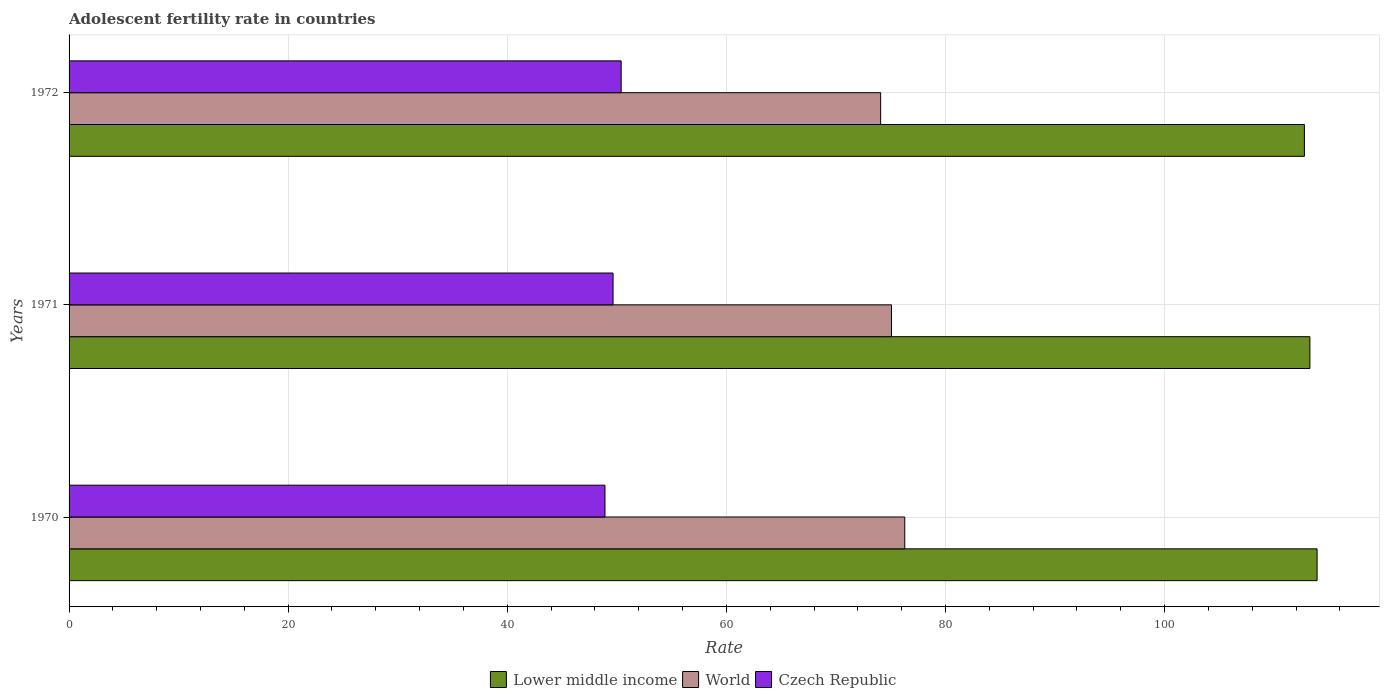How many different coloured bars are there?
Provide a short and direct response. 3. Are the number of bars per tick equal to the number of legend labels?
Ensure brevity in your answer.  Yes. What is the label of the 2nd group of bars from the top?
Keep it short and to the point. 1971. In how many cases, is the number of bars for a given year not equal to the number of legend labels?
Your answer should be compact. 0. What is the adolescent fertility rate in Czech Republic in 1972?
Your response must be concise. 50.4. Across all years, what is the maximum adolescent fertility rate in Lower middle income?
Your answer should be compact. 113.92. Across all years, what is the minimum adolescent fertility rate in Czech Republic?
Make the answer very short. 48.92. In which year was the adolescent fertility rate in World maximum?
Keep it short and to the point. 1970. In which year was the adolescent fertility rate in Lower middle income minimum?
Make the answer very short. 1972. What is the total adolescent fertility rate in World in the graph?
Ensure brevity in your answer.  225.44. What is the difference between the adolescent fertility rate in World in 1971 and that in 1972?
Make the answer very short. 0.99. What is the difference between the adolescent fertility rate in Czech Republic in 1971 and the adolescent fertility rate in Lower middle income in 1972?
Give a very brief answer. -63.11. What is the average adolescent fertility rate in Czech Republic per year?
Provide a succinct answer. 49.66. In the year 1970, what is the difference between the adolescent fertility rate in Lower middle income and adolescent fertility rate in Czech Republic?
Your answer should be compact. 65.01. What is the ratio of the adolescent fertility rate in World in 1970 to that in 1971?
Your answer should be very brief. 1.02. Is the adolescent fertility rate in Czech Republic in 1970 less than that in 1972?
Make the answer very short. Yes. Is the difference between the adolescent fertility rate in Lower middle income in 1970 and 1971 greater than the difference between the adolescent fertility rate in Czech Republic in 1970 and 1971?
Your answer should be compact. Yes. What is the difference between the highest and the second highest adolescent fertility rate in Lower middle income?
Your answer should be compact. 0.66. What is the difference between the highest and the lowest adolescent fertility rate in World?
Provide a short and direct response. 2.2. In how many years, is the adolescent fertility rate in Czech Republic greater than the average adolescent fertility rate in Czech Republic taken over all years?
Your answer should be very brief. 1. What does the 1st bar from the top in 1970 represents?
Your response must be concise. Czech Republic. Is it the case that in every year, the sum of the adolescent fertility rate in Lower middle income and adolescent fertility rate in Czech Republic is greater than the adolescent fertility rate in World?
Your answer should be compact. Yes. How many bars are there?
Offer a terse response. 9. How many years are there in the graph?
Your answer should be very brief. 3. What is the difference between two consecutive major ticks on the X-axis?
Keep it short and to the point. 20. Are the values on the major ticks of X-axis written in scientific E-notation?
Provide a short and direct response. No. Does the graph contain grids?
Offer a very short reply. Yes. What is the title of the graph?
Give a very brief answer. Adolescent fertility rate in countries. What is the label or title of the X-axis?
Offer a terse response. Rate. What is the label or title of the Y-axis?
Make the answer very short. Years. What is the Rate of Lower middle income in 1970?
Provide a short and direct response. 113.92. What is the Rate in World in 1970?
Give a very brief answer. 76.29. What is the Rate of Czech Republic in 1970?
Ensure brevity in your answer.  48.92. What is the Rate of Lower middle income in 1971?
Make the answer very short. 113.27. What is the Rate of World in 1971?
Ensure brevity in your answer.  75.07. What is the Rate in Czech Republic in 1971?
Your answer should be very brief. 49.66. What is the Rate of Lower middle income in 1972?
Make the answer very short. 112.77. What is the Rate of World in 1972?
Provide a succinct answer. 74.08. What is the Rate of Czech Republic in 1972?
Your response must be concise. 50.4. Across all years, what is the maximum Rate in Lower middle income?
Your answer should be very brief. 113.92. Across all years, what is the maximum Rate in World?
Provide a succinct answer. 76.29. Across all years, what is the maximum Rate of Czech Republic?
Offer a very short reply. 50.4. Across all years, what is the minimum Rate in Lower middle income?
Provide a succinct answer. 112.77. Across all years, what is the minimum Rate in World?
Provide a succinct answer. 74.08. Across all years, what is the minimum Rate in Czech Republic?
Provide a succinct answer. 48.92. What is the total Rate in Lower middle income in the graph?
Provide a succinct answer. 339.96. What is the total Rate in World in the graph?
Provide a short and direct response. 225.44. What is the total Rate in Czech Republic in the graph?
Give a very brief answer. 148.97. What is the difference between the Rate in Lower middle income in 1970 and that in 1971?
Give a very brief answer. 0.66. What is the difference between the Rate in World in 1970 and that in 1971?
Provide a short and direct response. 1.21. What is the difference between the Rate in Czech Republic in 1970 and that in 1971?
Make the answer very short. -0.74. What is the difference between the Rate of Lower middle income in 1970 and that in 1972?
Your response must be concise. 1.16. What is the difference between the Rate in World in 1970 and that in 1972?
Give a very brief answer. 2.2. What is the difference between the Rate in Czech Republic in 1970 and that in 1972?
Your answer should be very brief. -1.48. What is the difference between the Rate of Lower middle income in 1971 and that in 1972?
Make the answer very short. 0.5. What is the difference between the Rate in Czech Republic in 1971 and that in 1972?
Your answer should be compact. -0.74. What is the difference between the Rate in Lower middle income in 1970 and the Rate in World in 1971?
Provide a succinct answer. 38.85. What is the difference between the Rate of Lower middle income in 1970 and the Rate of Czech Republic in 1971?
Provide a succinct answer. 64.27. What is the difference between the Rate in World in 1970 and the Rate in Czech Republic in 1971?
Your answer should be compact. 26.63. What is the difference between the Rate of Lower middle income in 1970 and the Rate of World in 1972?
Your answer should be compact. 39.84. What is the difference between the Rate of Lower middle income in 1970 and the Rate of Czech Republic in 1972?
Provide a short and direct response. 63.53. What is the difference between the Rate of World in 1970 and the Rate of Czech Republic in 1972?
Your answer should be very brief. 25.89. What is the difference between the Rate of Lower middle income in 1971 and the Rate of World in 1972?
Offer a very short reply. 39.19. What is the difference between the Rate in Lower middle income in 1971 and the Rate in Czech Republic in 1972?
Your answer should be compact. 62.87. What is the difference between the Rate of World in 1971 and the Rate of Czech Republic in 1972?
Your answer should be very brief. 24.68. What is the average Rate of Lower middle income per year?
Provide a succinct answer. 113.32. What is the average Rate of World per year?
Offer a terse response. 75.15. What is the average Rate in Czech Republic per year?
Offer a terse response. 49.66. In the year 1970, what is the difference between the Rate of Lower middle income and Rate of World?
Make the answer very short. 37.64. In the year 1970, what is the difference between the Rate in Lower middle income and Rate in Czech Republic?
Make the answer very short. 65.01. In the year 1970, what is the difference between the Rate in World and Rate in Czech Republic?
Give a very brief answer. 27.37. In the year 1971, what is the difference between the Rate in Lower middle income and Rate in World?
Your answer should be compact. 38.2. In the year 1971, what is the difference between the Rate in Lower middle income and Rate in Czech Republic?
Make the answer very short. 63.61. In the year 1971, what is the difference between the Rate of World and Rate of Czech Republic?
Your response must be concise. 25.41. In the year 1972, what is the difference between the Rate in Lower middle income and Rate in World?
Your answer should be compact. 38.68. In the year 1972, what is the difference between the Rate in Lower middle income and Rate in Czech Republic?
Provide a succinct answer. 62.37. In the year 1972, what is the difference between the Rate of World and Rate of Czech Republic?
Provide a succinct answer. 23.69. What is the ratio of the Rate of Lower middle income in 1970 to that in 1971?
Your answer should be very brief. 1.01. What is the ratio of the Rate of World in 1970 to that in 1971?
Your response must be concise. 1.02. What is the ratio of the Rate of Czech Republic in 1970 to that in 1971?
Make the answer very short. 0.99. What is the ratio of the Rate in Lower middle income in 1970 to that in 1972?
Your answer should be very brief. 1.01. What is the ratio of the Rate of World in 1970 to that in 1972?
Your response must be concise. 1.03. What is the ratio of the Rate in Czech Republic in 1970 to that in 1972?
Your answer should be compact. 0.97. What is the ratio of the Rate of Lower middle income in 1971 to that in 1972?
Provide a succinct answer. 1. What is the ratio of the Rate in World in 1971 to that in 1972?
Offer a very short reply. 1.01. What is the ratio of the Rate of Czech Republic in 1971 to that in 1972?
Make the answer very short. 0.99. What is the difference between the highest and the second highest Rate of Lower middle income?
Your answer should be very brief. 0.66. What is the difference between the highest and the second highest Rate of World?
Make the answer very short. 1.21. What is the difference between the highest and the second highest Rate in Czech Republic?
Make the answer very short. 0.74. What is the difference between the highest and the lowest Rate of Lower middle income?
Your answer should be very brief. 1.16. What is the difference between the highest and the lowest Rate in World?
Provide a short and direct response. 2.2. What is the difference between the highest and the lowest Rate in Czech Republic?
Provide a short and direct response. 1.48. 